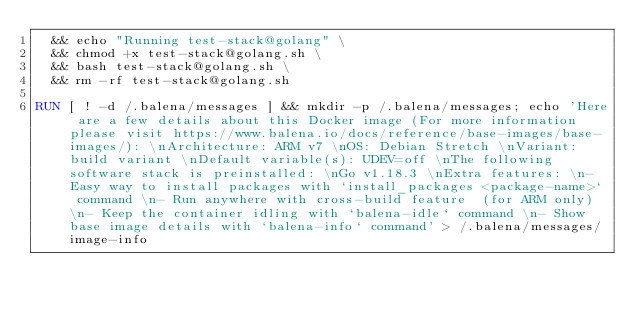Convert code to text. <code><loc_0><loc_0><loc_500><loc_500><_Dockerfile_>  && echo "Running test-stack@golang" \
  && chmod +x test-stack@golang.sh \
  && bash test-stack@golang.sh \
  && rm -rf test-stack@golang.sh 

RUN [ ! -d /.balena/messages ] && mkdir -p /.balena/messages; echo 'Here are a few details about this Docker image (For more information please visit https://www.balena.io/docs/reference/base-images/base-images/): \nArchitecture: ARM v7 \nOS: Debian Stretch \nVariant: build variant \nDefault variable(s): UDEV=off \nThe following software stack is preinstalled: \nGo v1.18.3 \nExtra features: \n- Easy way to install packages with `install_packages <package-name>` command \n- Run anywhere with cross-build feature  (for ARM only) \n- Keep the container idling with `balena-idle` command \n- Show base image details with `balena-info` command' > /.balena/messages/image-info</code> 